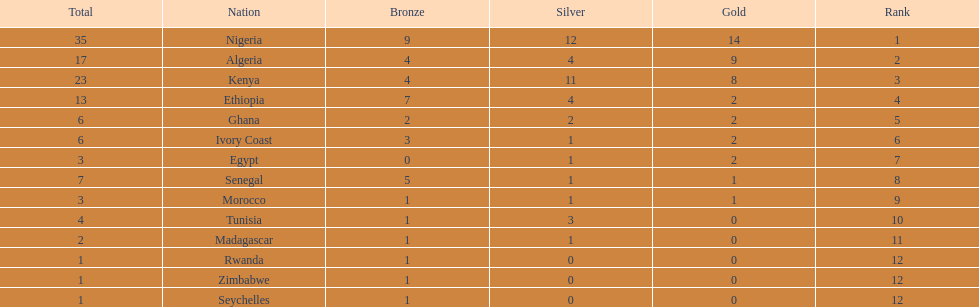Which nation secured the highest number of medals? Nigeria. 